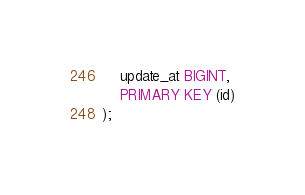Convert code to text. <code><loc_0><loc_0><loc_500><loc_500><_SQL_>	update_at BIGINT,
	PRIMARY KEY (id)
);
</code> 